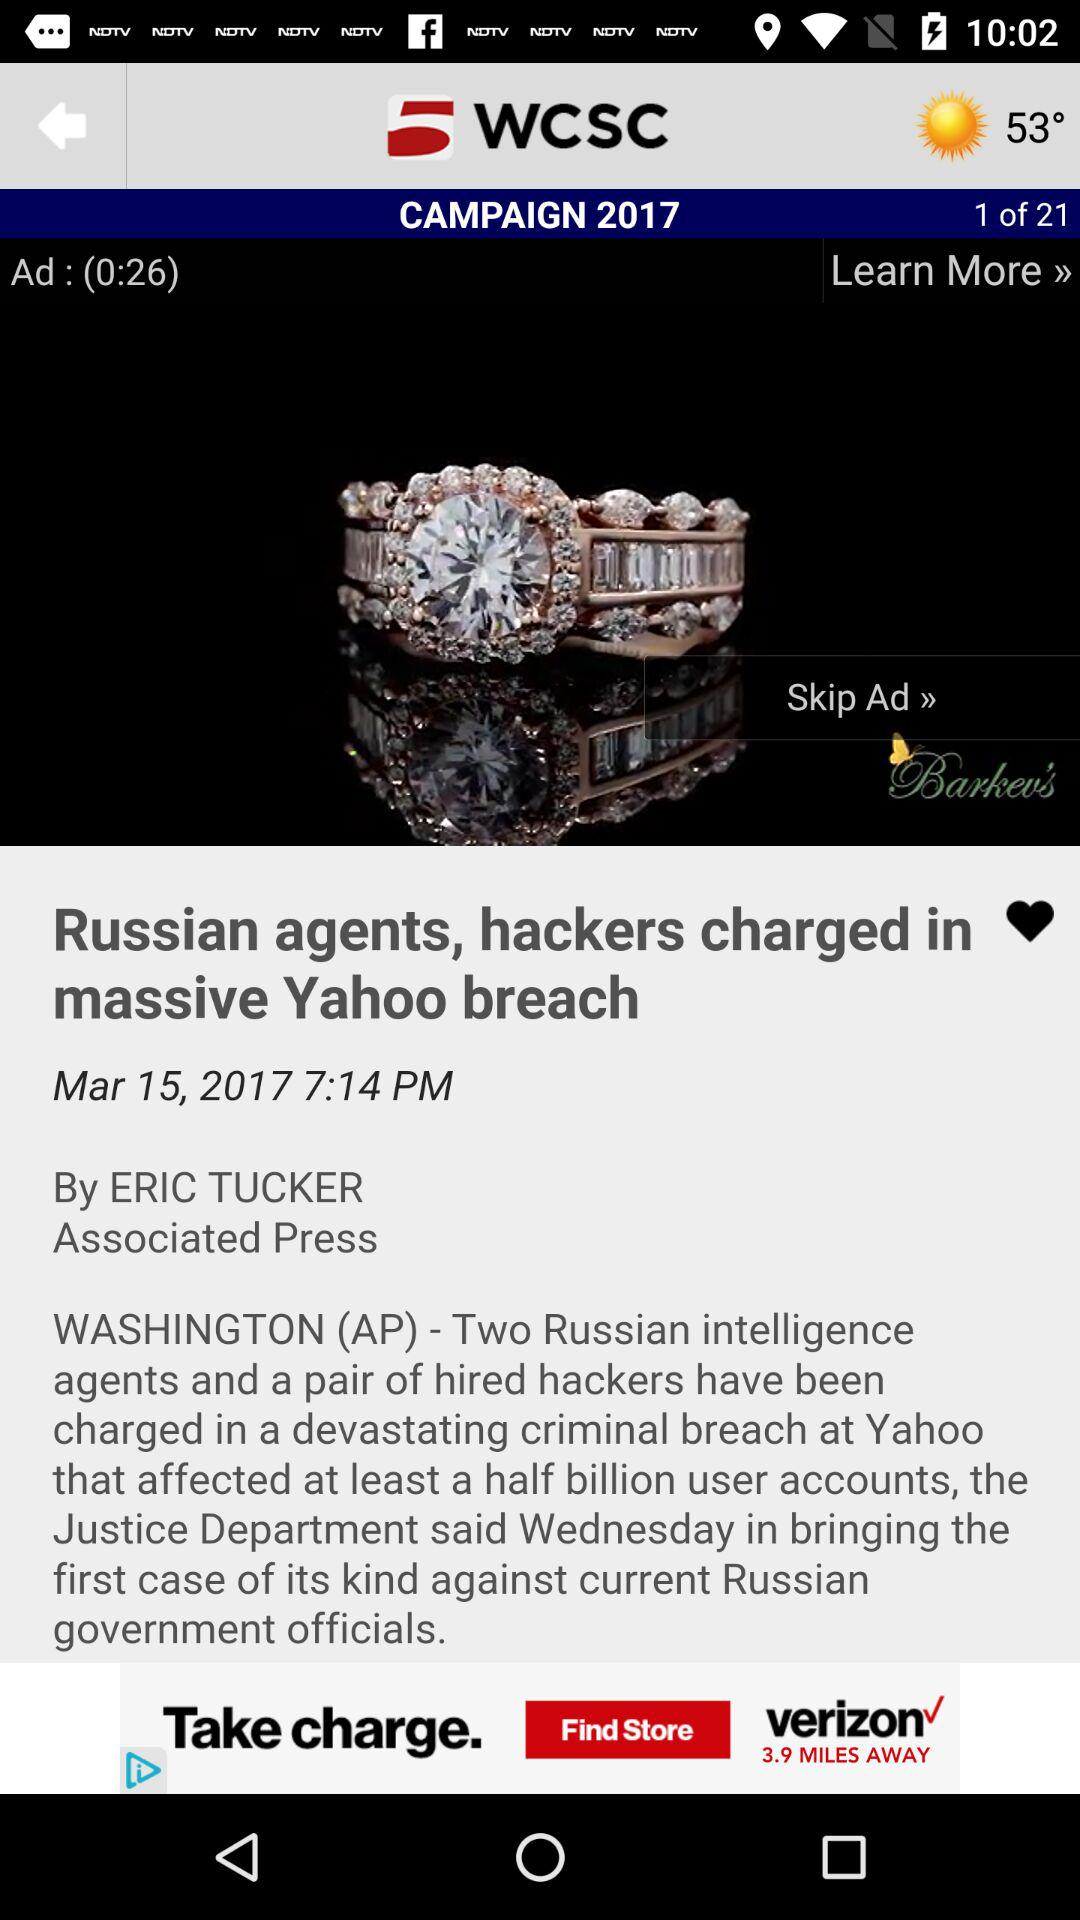Who is the author of "Russian agents, hackers charged in massive Yahoo breach"? The author is Eric Tucker. 